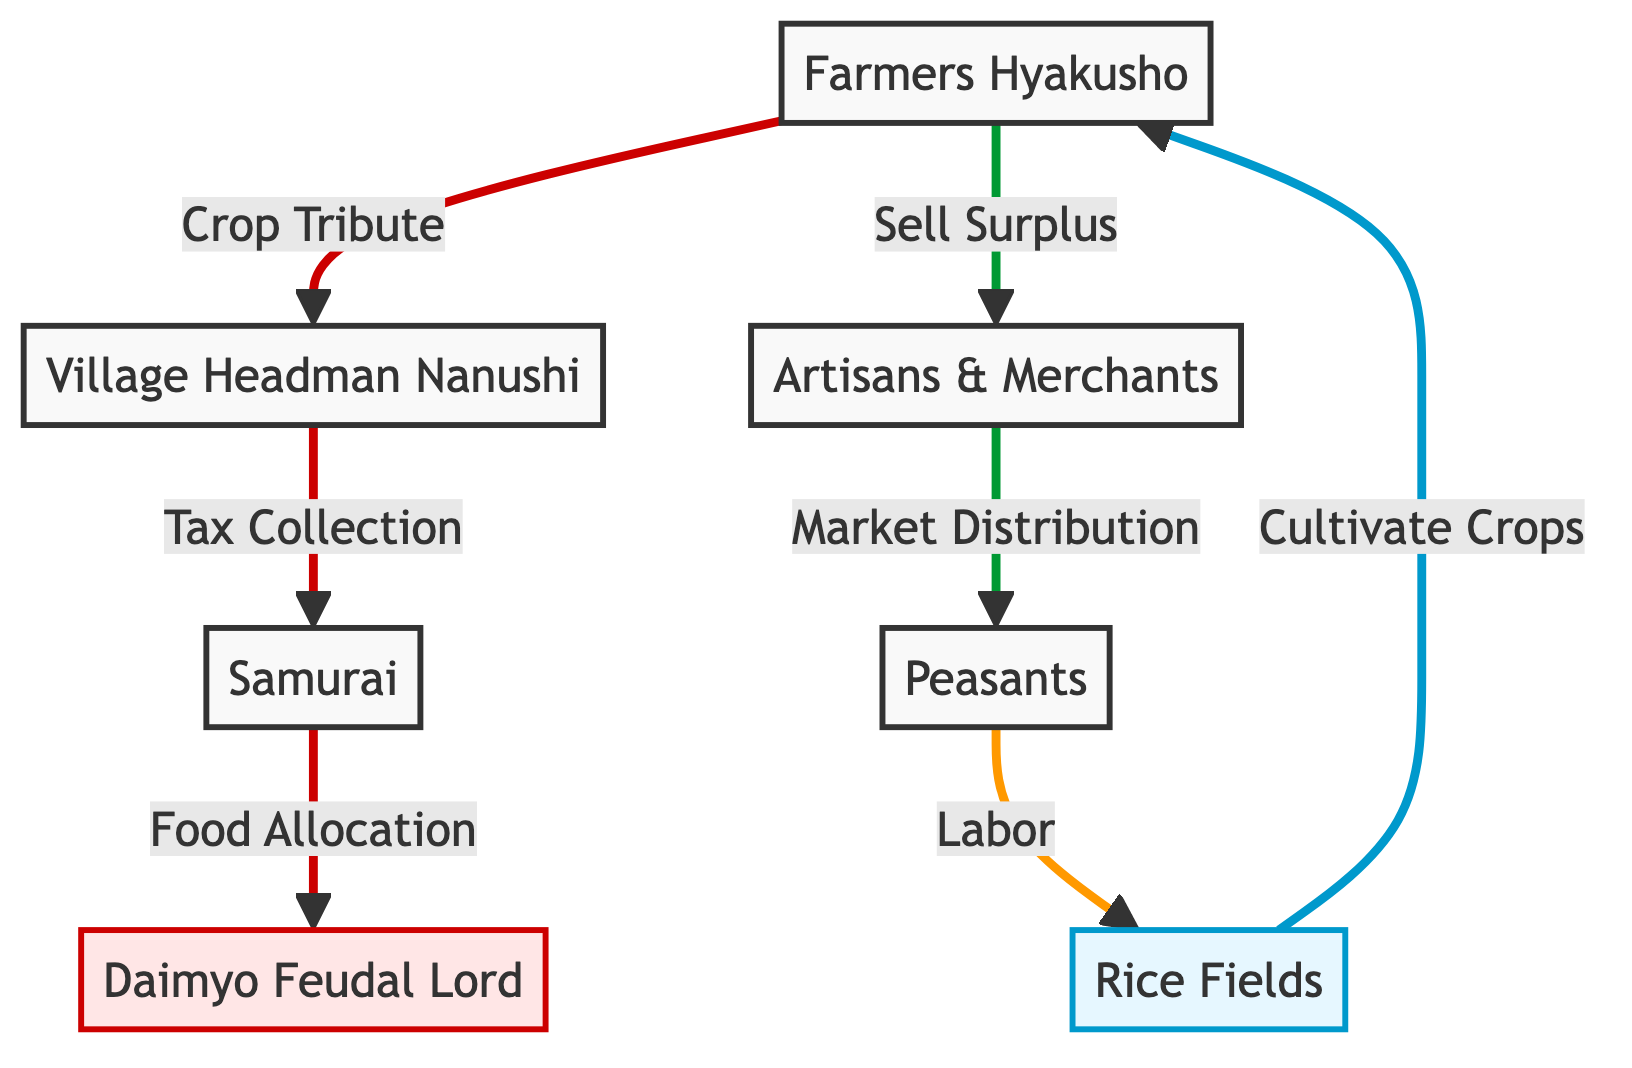What is the highest position in the food chain? The highest position in the food chain is represented by the node for the Daimyo Feudal Lord, indicating their top-tier authority in agricultural production and food allocation.
Answer: Daimyo Feudal Lord How many nodes are present in the diagram? The diagram contains a total of 7 distinct nodes, each representing different entities or groups involved in the agricultural production process in the Edo period.
Answer: 7 What do Farmers Hyakusho primarily do in this diagram? Farmers Hyakusho are primarily responsible for cultivating crops, as indicated by the direct connection from the Rice Fields to the Farmers Hyakusho node.
Answer: Cultivate Crops Who collects taxes from the Farmers Hyakusho? The taxes from the Farmers Hyakusho are collected by the Village Headman Nanushi, as shown by the flow connecting the Farmers Hyakusho to the Village Headman node in the hierarchy.
Answer: Village Headman Nanushi What happens to the surplus crops after they are harvested? The surplus crops harvested by the Farmers Hyakusho are sold to Artisans & Merchants, as indicated by the direct link between these two nodes in the flowchart.
Answer: Sell Surplus How does food reach the Samurai? Food reaches the Samurai through the tax collection process, wherein the Village Headman Nanushi allocates food collected from the Farmers Hyakusho, which is then passed to the Samurai.
Answer: Tax Collection What role do Artisans & Merchants play in the distribution of food? Artisans & Merchants are responsible for market distribution, as shown by their direct link to the Peasants and the process flow illustrated in the diagram.
Answer: Market Distribution What type of relationship exists between Peasants and Rice Fields? Peasants have a labor relationship with Rice Fields, as indicated by the link connecting the Peasants to Rice Fields, where they engage in productive work.
Answer: Labor How is food allocated in the hierarchy represented in this diagram? Food allocation occurs through a sequence that starts from crop tribute by Farmers to the Village Headman, then from the Village Headman to the Samurai, which illustrates the structured allocation process.
Answer: Food Allocation 